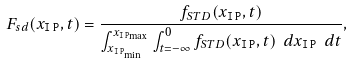<formula> <loc_0><loc_0><loc_500><loc_500>F _ { s d } ( x _ { \tt I \, P } , t ) = \frac { f _ { S T D } ( x _ { \tt I \, P } , t ) } { \int _ { x _ { { \tt I \, P } _ { \min } } } ^ { x _ { { \tt I \, P } _ { \max } } } \int ^ { 0 } _ { t = - \infty } f _ { S T D } ( x _ { \tt I \, P } , t ) \ d x _ { \tt I \, P } \ d t } ,</formula> 